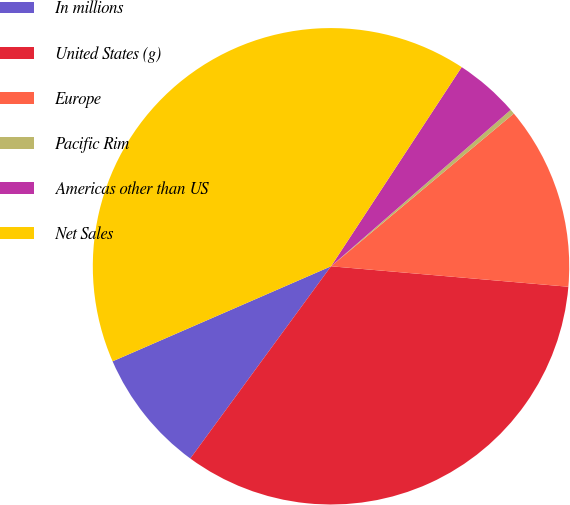Convert chart. <chart><loc_0><loc_0><loc_500><loc_500><pie_chart><fcel>In millions<fcel>United States (g)<fcel>Europe<fcel>Pacific Rim<fcel>Americas other than US<fcel>Net Sales<nl><fcel>8.41%<fcel>33.69%<fcel>12.45%<fcel>0.32%<fcel>4.36%<fcel>40.77%<nl></chart> 